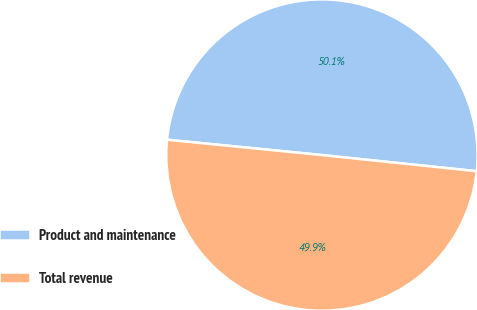Convert chart. <chart><loc_0><loc_0><loc_500><loc_500><pie_chart><fcel>Product and maintenance<fcel>Total revenue<nl><fcel>50.08%<fcel>49.92%<nl></chart> 